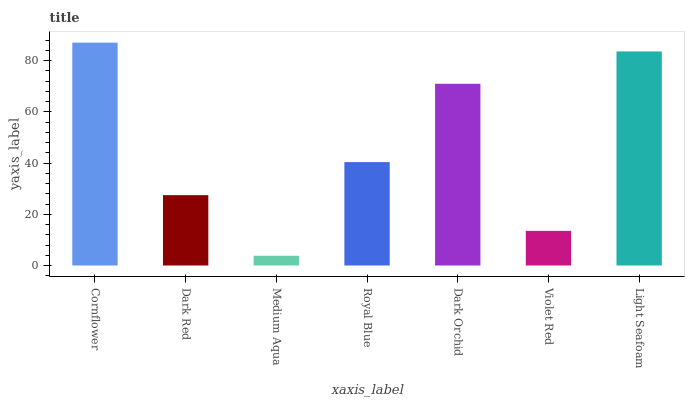Is Medium Aqua the minimum?
Answer yes or no. Yes. Is Cornflower the maximum?
Answer yes or no. Yes. Is Dark Red the minimum?
Answer yes or no. No. Is Dark Red the maximum?
Answer yes or no. No. Is Cornflower greater than Dark Red?
Answer yes or no. Yes. Is Dark Red less than Cornflower?
Answer yes or no. Yes. Is Dark Red greater than Cornflower?
Answer yes or no. No. Is Cornflower less than Dark Red?
Answer yes or no. No. Is Royal Blue the high median?
Answer yes or no. Yes. Is Royal Blue the low median?
Answer yes or no. Yes. Is Cornflower the high median?
Answer yes or no. No. Is Dark Red the low median?
Answer yes or no. No. 